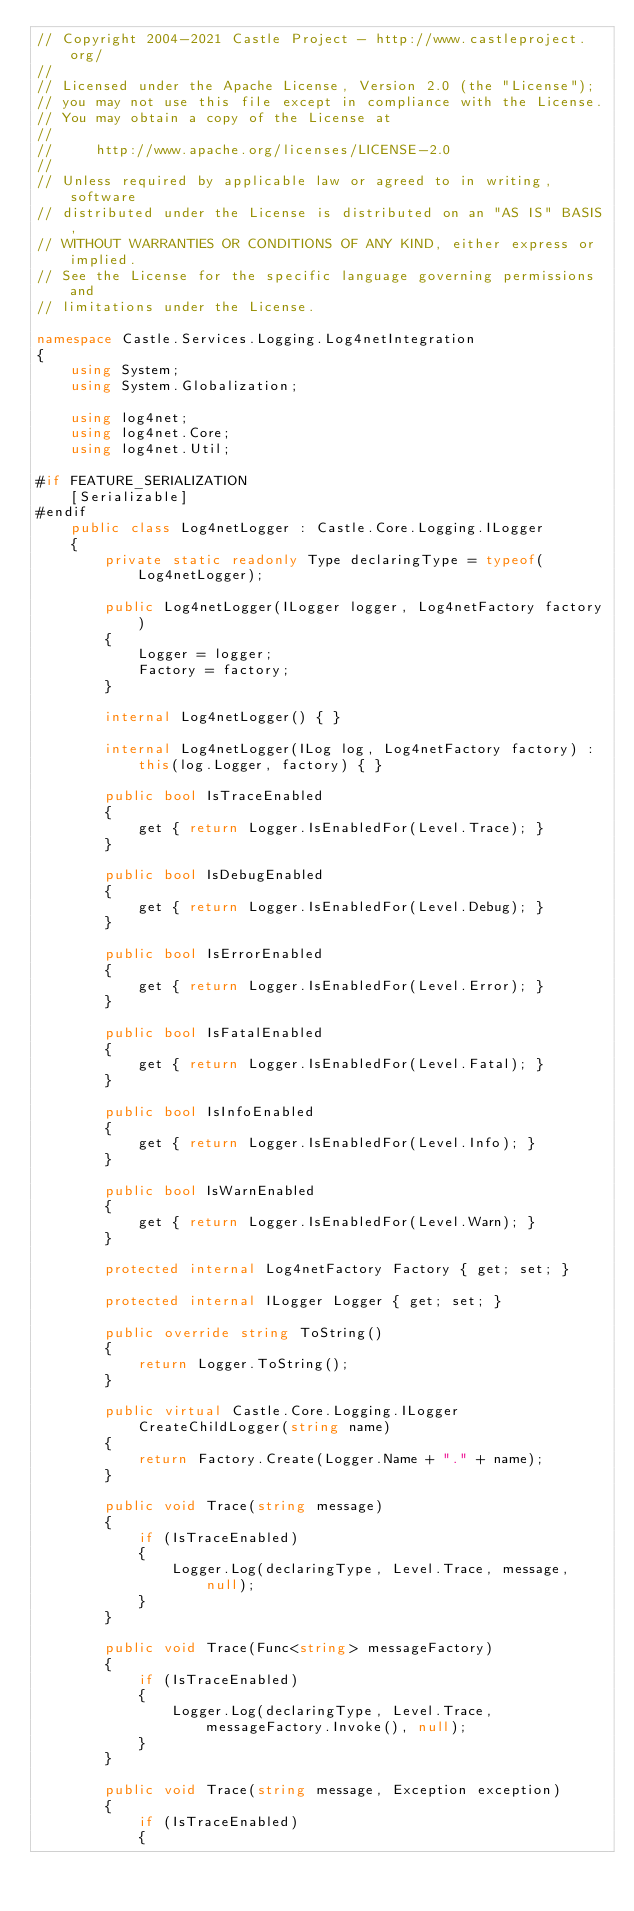Convert code to text. <code><loc_0><loc_0><loc_500><loc_500><_C#_>// Copyright 2004-2021 Castle Project - http://www.castleproject.org/
//
// Licensed under the Apache License, Version 2.0 (the "License");
// you may not use this file except in compliance with the License.
// You may obtain a copy of the License at
//
//     http://www.apache.org/licenses/LICENSE-2.0
//
// Unless required by applicable law or agreed to in writing, software
// distributed under the License is distributed on an "AS IS" BASIS,
// WITHOUT WARRANTIES OR CONDITIONS OF ANY KIND, either express or implied.
// See the License for the specific language governing permissions and
// limitations under the License.

namespace Castle.Services.Logging.Log4netIntegration
{
    using System;
    using System.Globalization;

    using log4net;
    using log4net.Core;
    using log4net.Util;

#if FEATURE_SERIALIZATION
    [Serializable]
#endif
    public class Log4netLogger : Castle.Core.Logging.ILogger
    {
        private static readonly Type declaringType = typeof(Log4netLogger);

        public Log4netLogger(ILogger logger, Log4netFactory factory)
        {
            Logger = logger;
            Factory = factory;
        }

        internal Log4netLogger() { }

        internal Log4netLogger(ILog log, Log4netFactory factory) : this(log.Logger, factory) { }

        public bool IsTraceEnabled
        {
            get { return Logger.IsEnabledFor(Level.Trace); }
        }

        public bool IsDebugEnabled
        {
            get { return Logger.IsEnabledFor(Level.Debug); }
        }

        public bool IsErrorEnabled
        {
            get { return Logger.IsEnabledFor(Level.Error); }
        }

        public bool IsFatalEnabled
        {
            get { return Logger.IsEnabledFor(Level.Fatal); }
        }

        public bool IsInfoEnabled
        {
            get { return Logger.IsEnabledFor(Level.Info); }
        }

        public bool IsWarnEnabled
        {
            get { return Logger.IsEnabledFor(Level.Warn); }
        }

        protected internal Log4netFactory Factory { get; set; }

        protected internal ILogger Logger { get; set; }

        public override string ToString()
        {
            return Logger.ToString();
        }

        public virtual Castle.Core.Logging.ILogger CreateChildLogger(string name)
        {
            return Factory.Create(Logger.Name + "." + name);
        }

        public void Trace(string message)
        {
            if (IsTraceEnabled)
            {
                Logger.Log(declaringType, Level.Trace, message, null);
            }
        }

        public void Trace(Func<string> messageFactory)
        {
            if (IsTraceEnabled)
            {
                Logger.Log(declaringType, Level.Trace, messageFactory.Invoke(), null);
            }
        }

        public void Trace(string message, Exception exception)
        {
            if (IsTraceEnabled)
            {</code> 